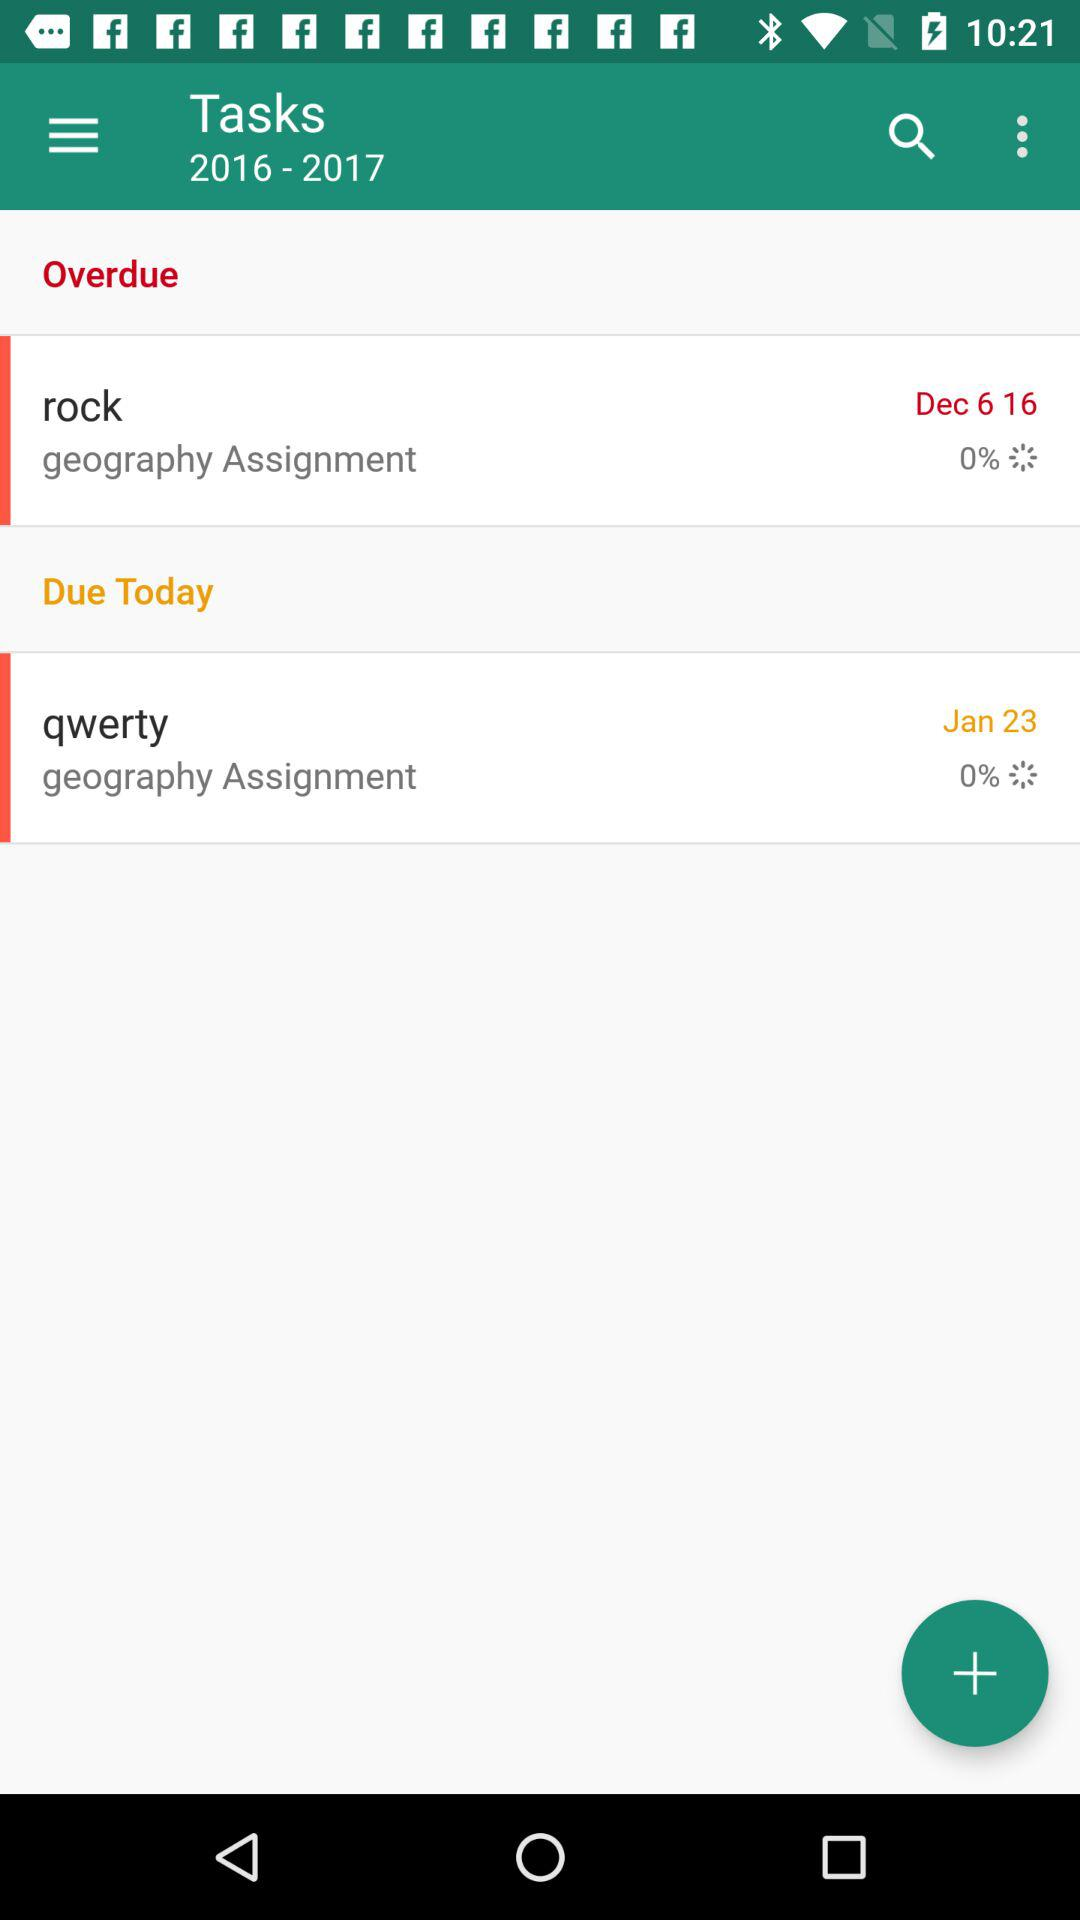How many tasks have a percentage completion of 0%?
Answer the question using a single word or phrase. 2 